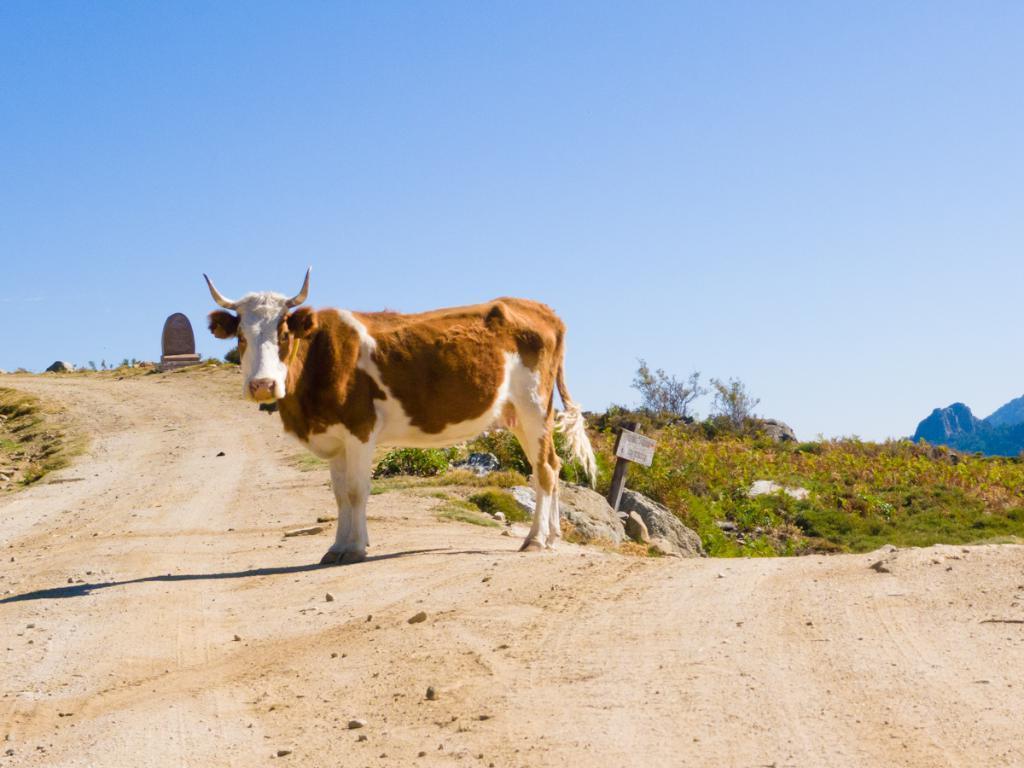How would you summarize this image in a sentence or two? In this image we can see a bull on the ground and in the background there are socks, grass, a wooden stick with board, mountains and the sky. 